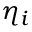<formula> <loc_0><loc_0><loc_500><loc_500>\eta _ { i }</formula> 